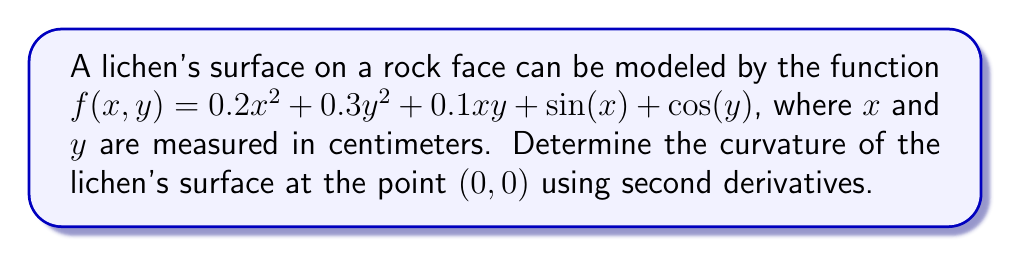Solve this math problem. To find the curvature of the lichen's surface at $(0,0)$, we need to calculate the Gaussian curvature using second partial derivatives. The steps are as follows:

1. Calculate the required second partial derivatives:
   $f_{xx} = \frac{\partial^2f}{\partial x^2} = 0.4 - \sin(x)$
   $f_{yy} = \frac{\partial^2f}{\partial y^2} = 0.6 - \cos(y)$
   $f_{xy} = \frac{\partial^2f}{\partial x\partial y} = 0.1$

2. Evaluate these derivatives at the point $(0,0)$:
   $f_{xx}(0,0) = 0.4 - \sin(0) = 0.4$
   $f_{yy}(0,0) = 0.6 - \cos(0) = -0.4$
   $f_{xy}(0,0) = 0.1$

3. Calculate the Gaussian curvature $K$ using the formula:
   $$K = \frac{f_{xx}f_{yy} - (f_{xy})^2}{(1 + (f_x)^2 + (f_y)^2)^2}$$

   At $(0,0)$, $f_x = f_y = 0$, so the denominator simplifies to 1.

4. Substitute the values:
   $$K = (0.4)(-0.4) - (0.1)^2 = -0.16 - 0.01 = -0.17$$

The negative curvature indicates that the lichen's surface has a saddle-like shape at $(0,0)$, reminiscent of the undulating forms often found in nature.
Answer: $-0.17$ cm$^{-2}$ 